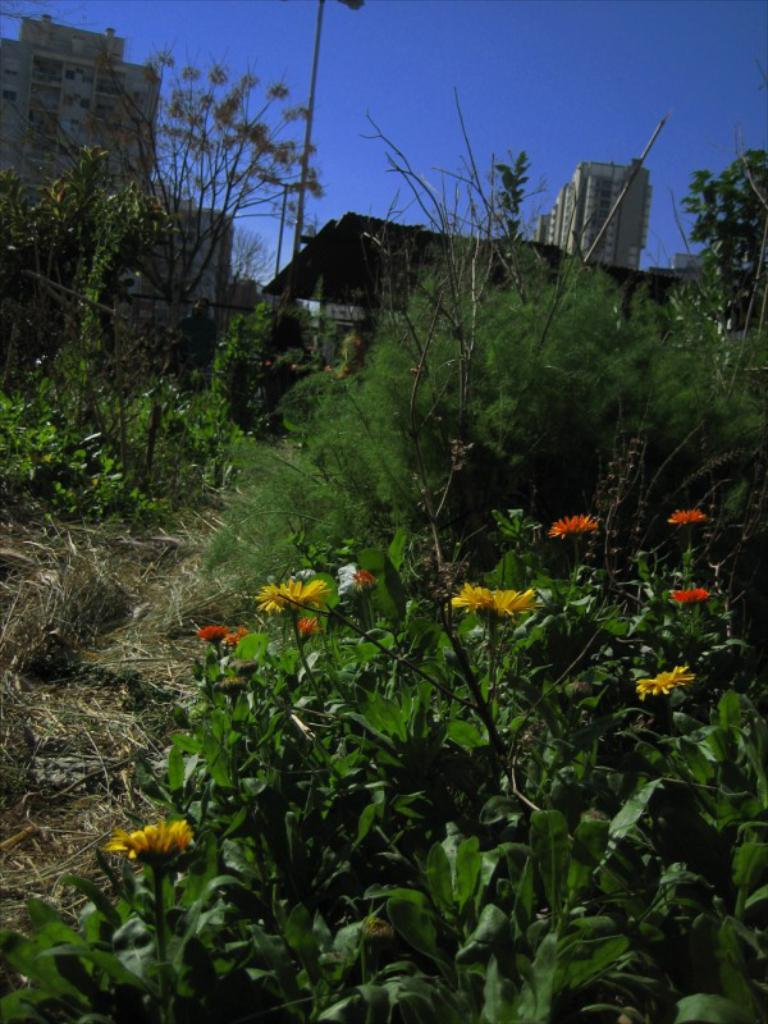What type of structures can be seen in the image? There are buildings in the image. What natural elements are present in the image? There are trees, plants, and flowers in the image. What type of lighting is present in the image? There is a pole light in the image. What is the color of the sky in the image? The sky is blue in the image. Can you describe the smoke coming from the frog in the image? There is no smoke or frog present in the image. What is the condition of the flowers in the image? The provided facts do not mention the condition of the flowers, only their presence. 